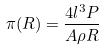Convert formula to latex. <formula><loc_0><loc_0><loc_500><loc_500>\pi ( R ) = \frac { 4 l ^ { 3 } P } { A \rho R }</formula> 